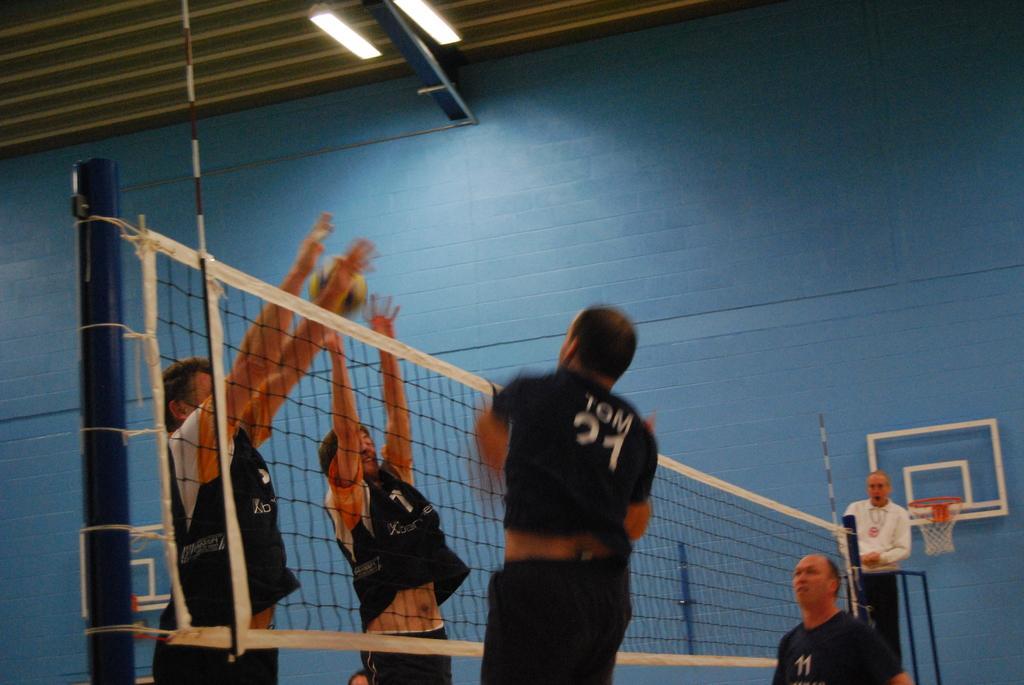How would you summarize this image in a sentence or two? At the top we can see the ceiling and the lights. In the background portion of the picture we can see the wall, a basketball hoop, few objects and a person. In this picture we can see a net, players are playing basketball game. We can see a ball in the air. 